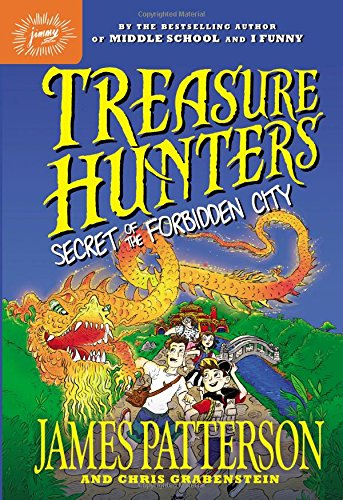Who might be the other contributors to this book besides James Patterson? Alongside James Patterson, Chris Grabenstein is also listed as a co-author on the cover, indicating his collaboration in crafting the thrilling narrative of 'Treasure Hunters: Secret of the Forbidden City.' 